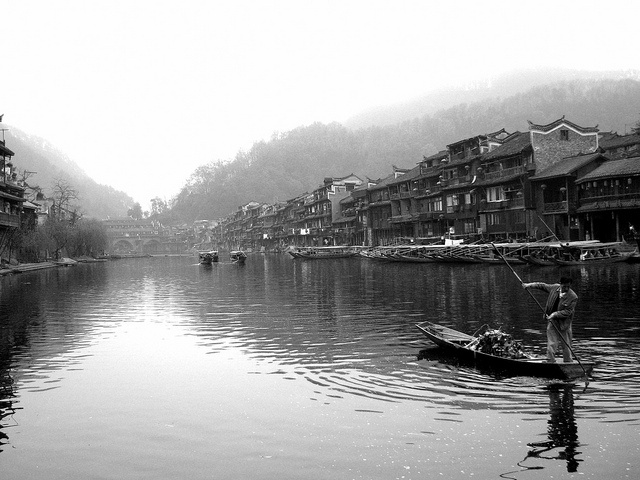Describe the objects in this image and their specific colors. I can see boat in white, black, gray, darkgray, and lightgray tones, people in white, black, gray, darkgray, and lightgray tones, boat in white, black, gray, darkgray, and lightgray tones, boat in white, black, gray, and lightgray tones, and boat in black, gray, and white tones in this image. 